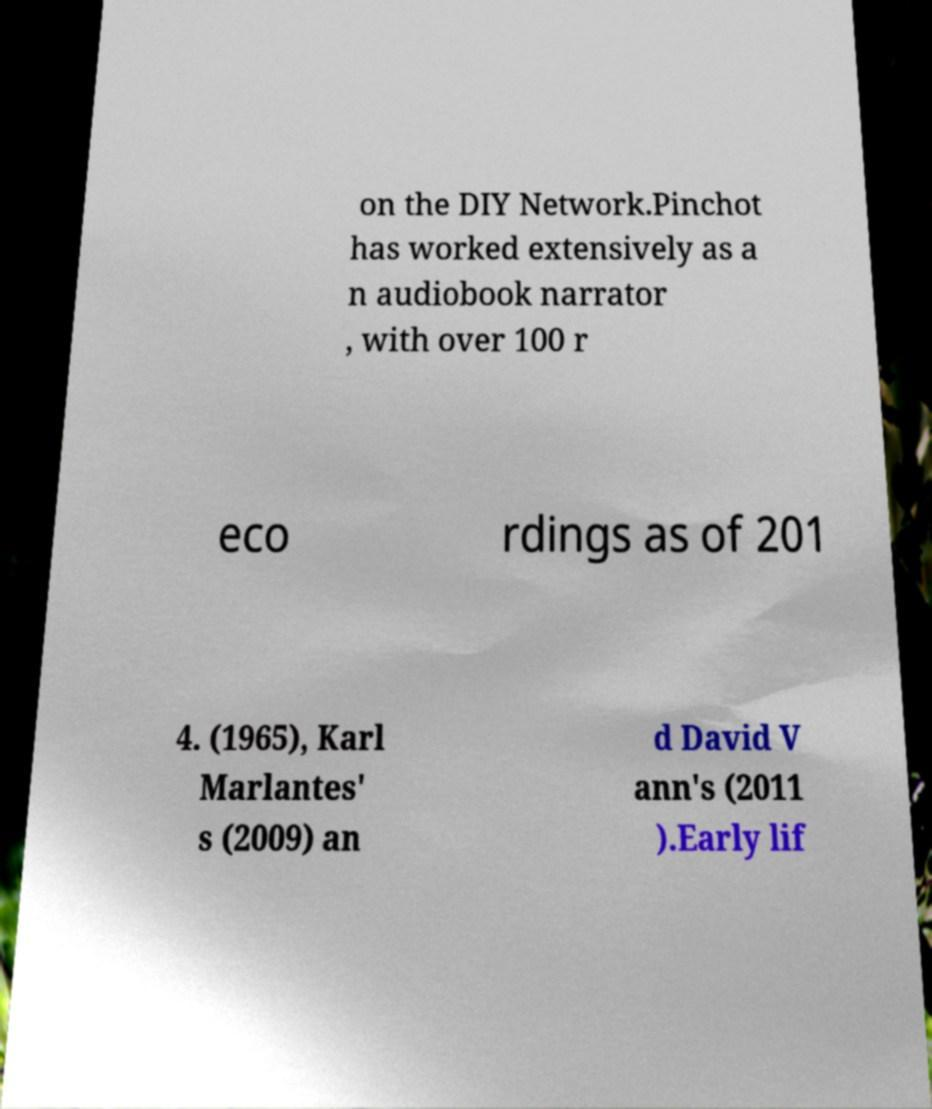Could you assist in decoding the text presented in this image and type it out clearly? on the DIY Network.Pinchot has worked extensively as a n audiobook narrator , with over 100 r eco rdings as of 201 4. (1965), Karl Marlantes' s (2009) an d David V ann's (2011 ).Early lif 